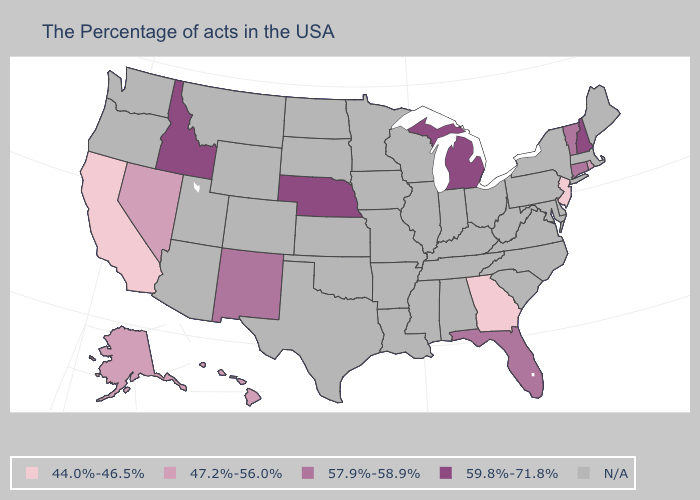Name the states that have a value in the range N/A?
Answer briefly. Maine, Massachusetts, New York, Delaware, Maryland, Pennsylvania, Virginia, North Carolina, South Carolina, West Virginia, Ohio, Kentucky, Indiana, Alabama, Tennessee, Wisconsin, Illinois, Mississippi, Louisiana, Missouri, Arkansas, Minnesota, Iowa, Kansas, Oklahoma, Texas, South Dakota, North Dakota, Wyoming, Colorado, Utah, Montana, Arizona, Washington, Oregon. Among the states that border Maine , which have the highest value?
Give a very brief answer. New Hampshire. Which states have the lowest value in the USA?
Short answer required. New Jersey, Georgia, California. What is the lowest value in the Northeast?
Concise answer only. 44.0%-46.5%. Is the legend a continuous bar?
Write a very short answer. No. What is the value of Kansas?
Be succinct. N/A. What is the value of Texas?
Short answer required. N/A. Which states have the highest value in the USA?
Be succinct. New Hampshire, Michigan, Nebraska, Idaho. Name the states that have a value in the range 57.9%-58.9%?
Give a very brief answer. Vermont, Connecticut, Florida, New Mexico. Is the legend a continuous bar?
Keep it brief. No. Name the states that have a value in the range 59.8%-71.8%?
Answer briefly. New Hampshire, Michigan, Nebraska, Idaho. What is the value of North Carolina?
Be succinct. N/A. Name the states that have a value in the range 57.9%-58.9%?
Write a very short answer. Vermont, Connecticut, Florida, New Mexico. Which states have the lowest value in the MidWest?
Short answer required. Michigan, Nebraska. 